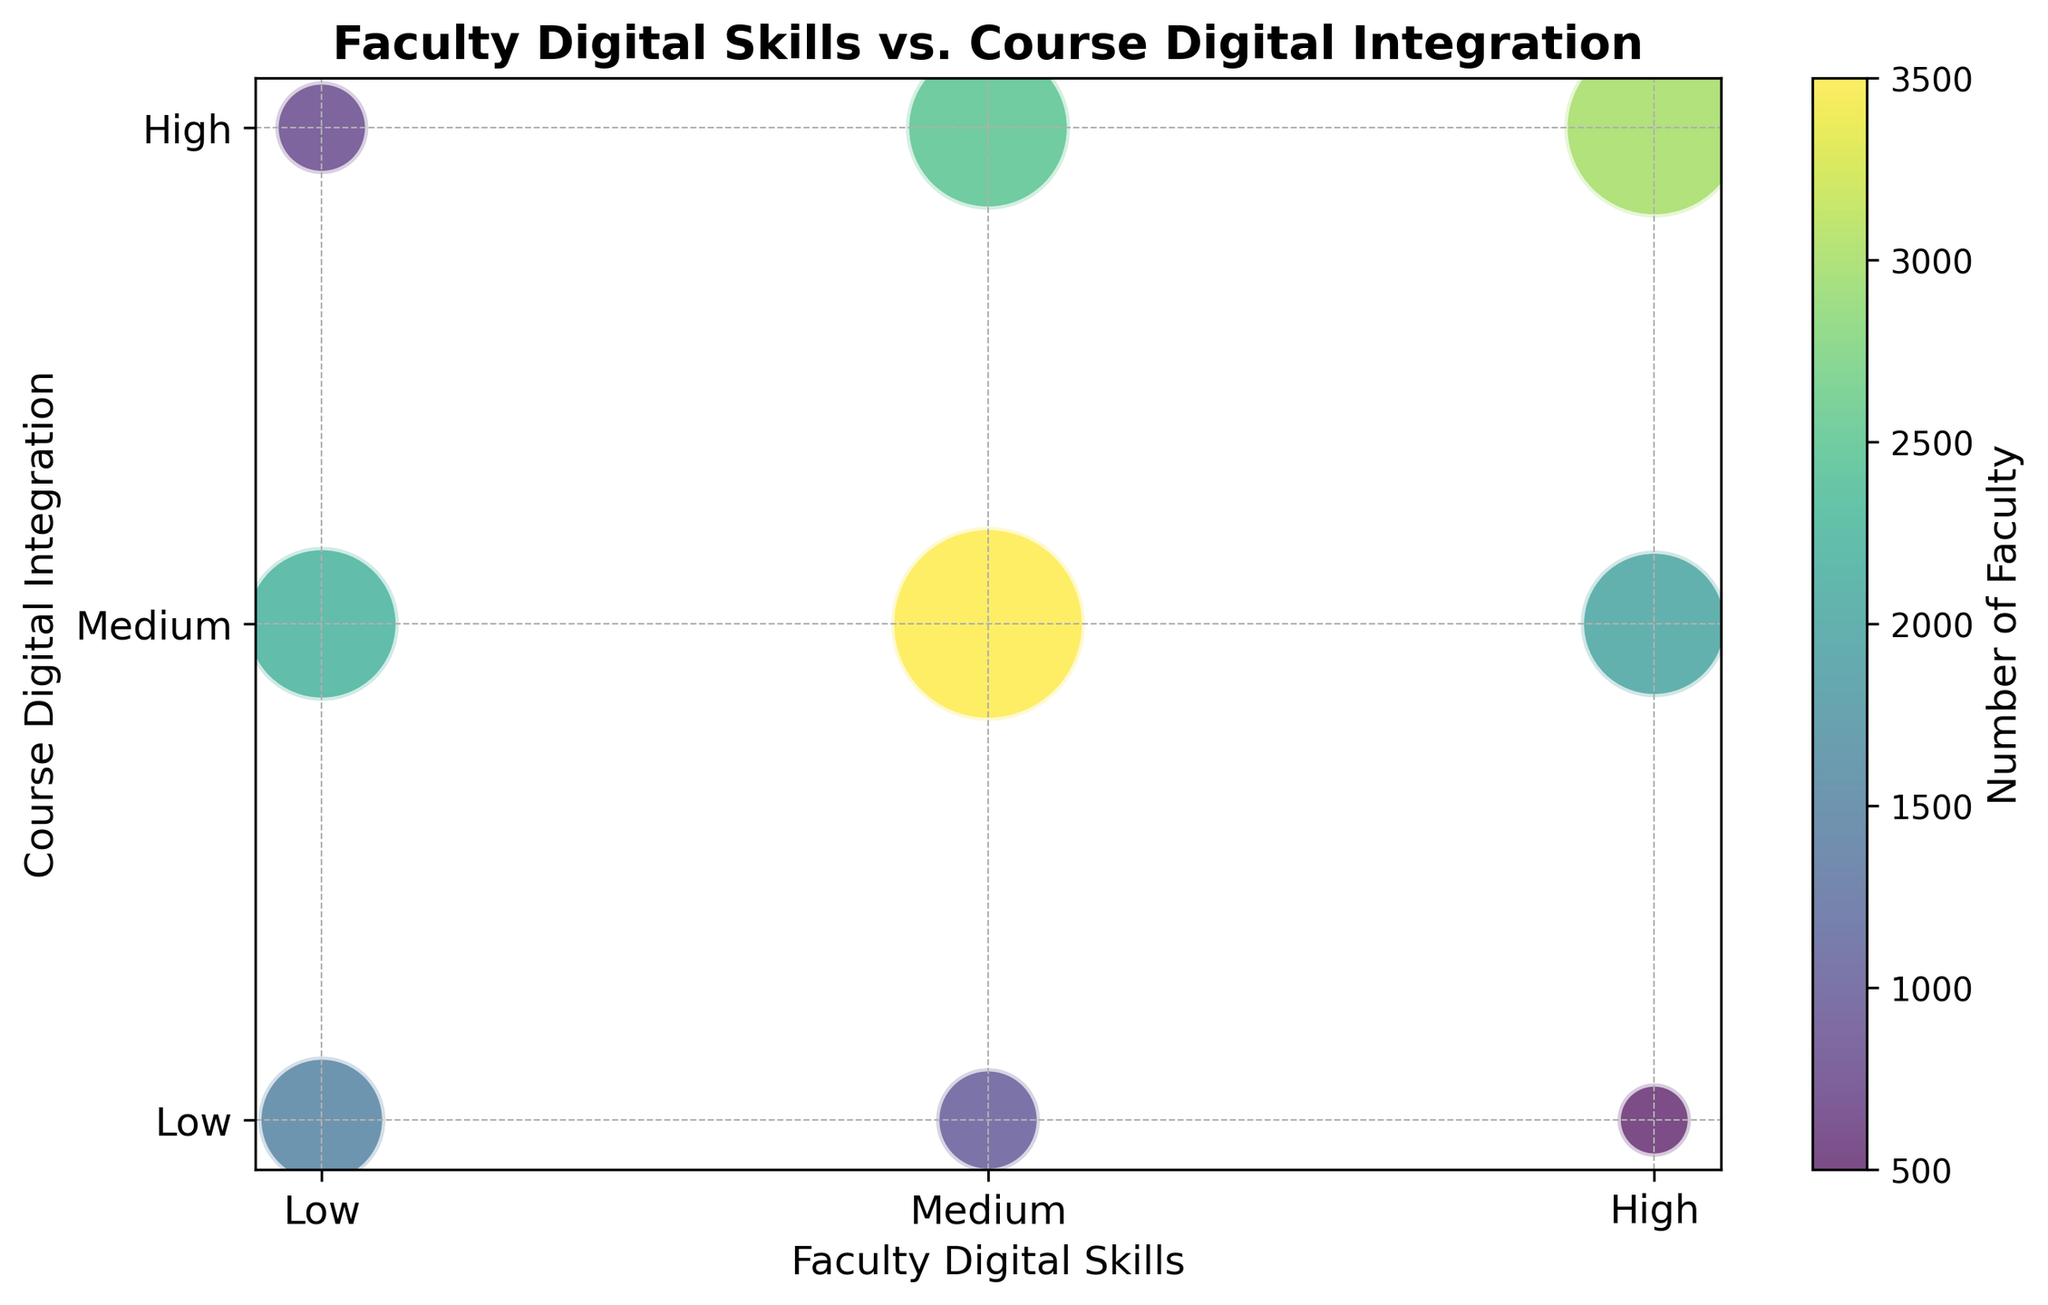Which category has the highest number of faculty members? The largest bubble represents the highest number of faculty. It is at the intersection of "Medium" Faculty Digital Skills and "Medium" Course Digital Integration.
Answer: Medium-Medium What is the number of faculty with high digital skills and low course integration? The bubble at the intersection of "High" Faculty Digital Skills and "Low" Course Digital Integration indicates the number of faculty, which is represented by the size of the bubble.
Answer: 5 Which has more faculty members: those with low digital skills but high course integration or those with high digital skills but low course integration? Compare the sizes of bubbles at intersections "Low-High" and "High-Low". The "Low-High" bubble is bigger.
Answer: Low-High How many faculty members are represented in the smallest bubble? Identify the smallest bubble in the plot and refer to its corresponding label. The smallest bubble is at "High-Low".
Answer: 5 What is the total number of faculty members with medium course integration? Sum the number of faculty at the intersections "Low-Medium", "Medium-Medium", and "High-Medium". This is 22 + 35 + 20 = 77.
Answer: 77 What is the total number of faculty members with high digital skills? Add the number of faculty at "High-Low", "High-Medium", and "High-High" which are represented by the bubbles. This is 5 + 20 + 30 = 55.
Answer: 55 Compare the number of faculty members with low digital skills and medium course integration to those with medium digital skills and high course integration. Compare the sizes of bubbles at "Low-Medium" and "Medium-High". The bubble for "Medium-High" is slightly larger.
Answer: Medium-High What is the relationship between faculty digital skills and course digital integration for the highest number of faculty? The largest bubble is in the "Medium" Faculty Digital Skills and "Medium" Course Digital Integration quadrant. Indicating this combination has the highest faculty representation.
Answer: Medium-Medium How many more faculty are there with medium digital skills and high course integration compared to those with low digital skills and high course integration? Subtract the number of faculty in “Low-High” from the number in “Medium-High”. 25-8 = 17.
Answer: 17 Which category has the least faculty members, and how many are there? Identify the smallest bubble on the chart, which is "High-Low". The number of faculty represented by the smallest bubble is 5.
Answer: High-Low, 5 